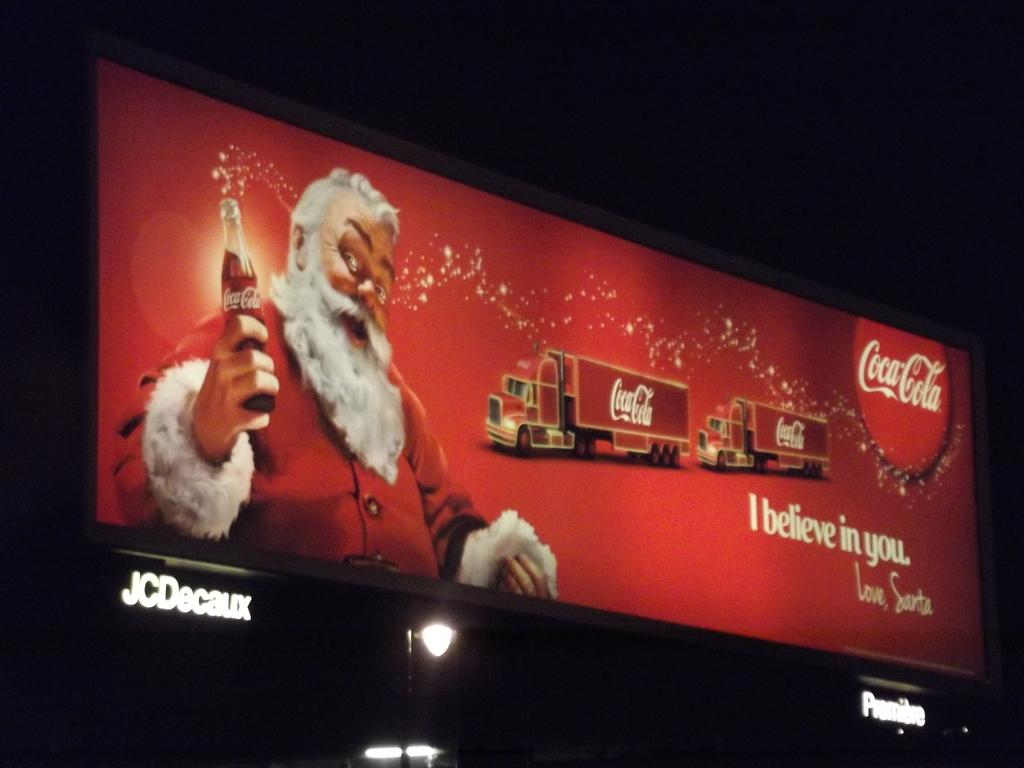<image>
Give a short and clear explanation of the subsequent image. An advertisement for Coca Cola has Santa Claus on it holding a bottle of soda. 